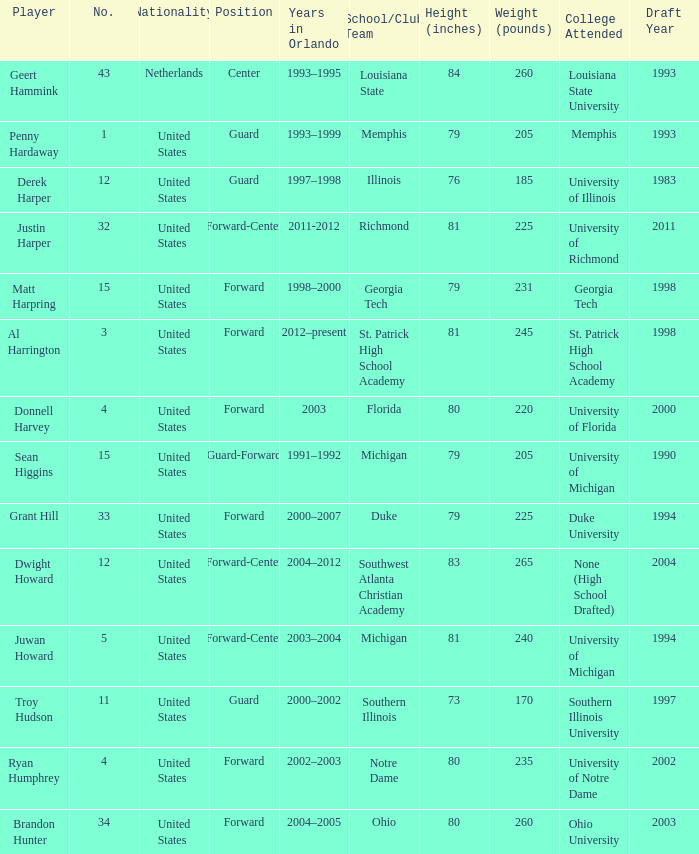What jersey number did Al Harrington wear 3.0. 